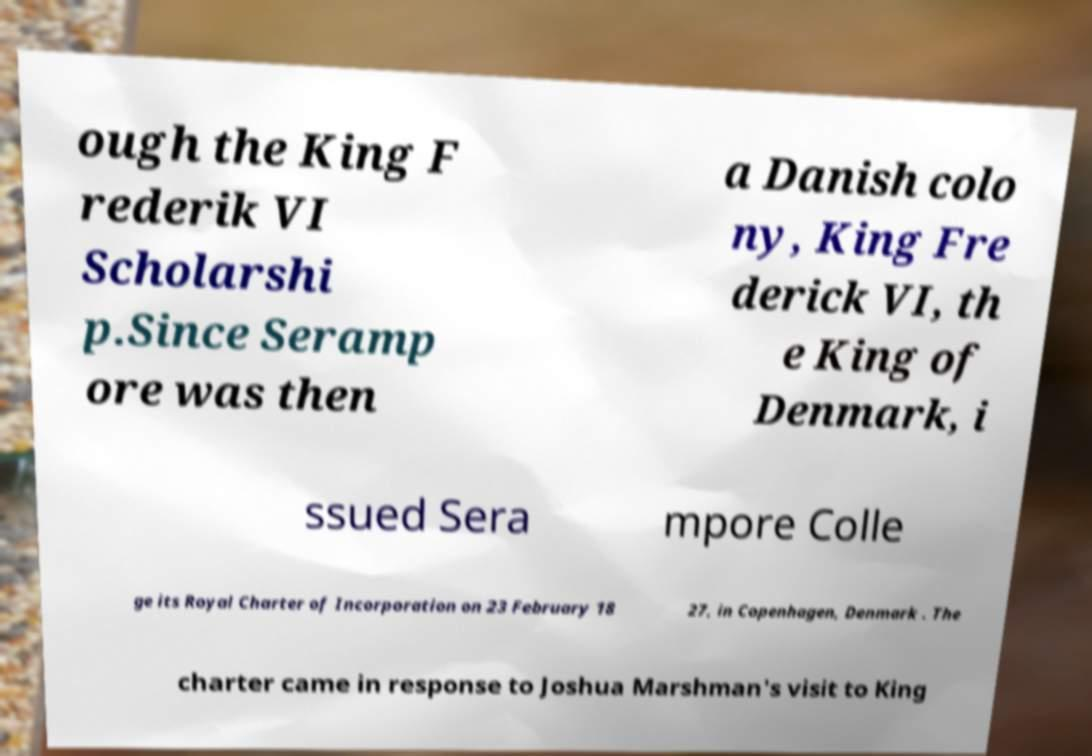I need the written content from this picture converted into text. Can you do that? ough the King F rederik VI Scholarshi p.Since Seramp ore was then a Danish colo ny, King Fre derick VI, th e King of Denmark, i ssued Sera mpore Colle ge its Royal Charter of Incorporation on 23 February 18 27, in Copenhagen, Denmark . The charter came in response to Joshua Marshman's visit to King 